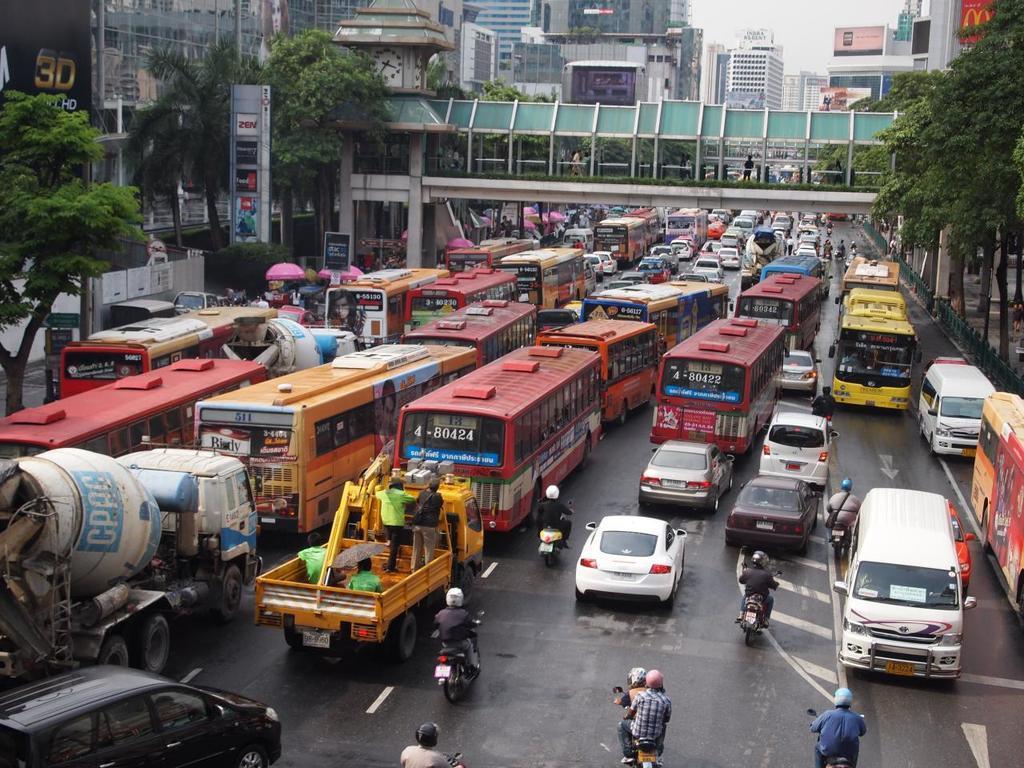In one or two sentences, can you explain what this image depicts? In this image, we can see a road, there are some cars, buses on the road, we can see a bridge and there are some trees, we can see some buildings. 